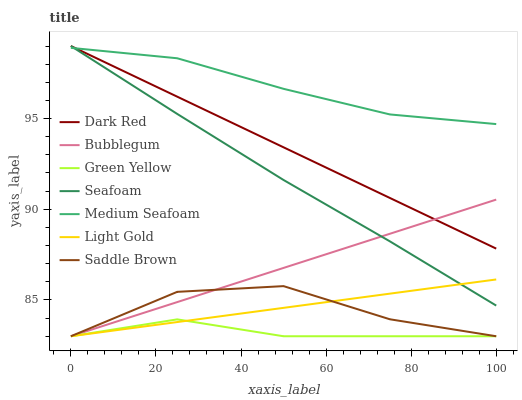Does Green Yellow have the minimum area under the curve?
Answer yes or no. Yes. Does Medium Seafoam have the maximum area under the curve?
Answer yes or no. Yes. Does Seafoam have the minimum area under the curve?
Answer yes or no. No. Does Seafoam have the maximum area under the curve?
Answer yes or no. No. Is Bubblegum the smoothest?
Answer yes or no. Yes. Is Saddle Brown the roughest?
Answer yes or no. Yes. Is Seafoam the smoothest?
Answer yes or no. No. Is Seafoam the roughest?
Answer yes or no. No. Does Bubblegum have the lowest value?
Answer yes or no. Yes. Does Seafoam have the lowest value?
Answer yes or no. No. Does Seafoam have the highest value?
Answer yes or no. Yes. Does Bubblegum have the highest value?
Answer yes or no. No. Is Light Gold less than Dark Red?
Answer yes or no. Yes. Is Medium Seafoam greater than Saddle Brown?
Answer yes or no. Yes. Does Dark Red intersect Medium Seafoam?
Answer yes or no. Yes. Is Dark Red less than Medium Seafoam?
Answer yes or no. No. Is Dark Red greater than Medium Seafoam?
Answer yes or no. No. Does Light Gold intersect Dark Red?
Answer yes or no. No. 